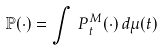Convert formula to latex. <formula><loc_0><loc_0><loc_500><loc_500>\mathbb { P ( \cdot ) } = \int \, P _ { t } ^ { M } ( \cdot ) \, d \mu ( t )</formula> 